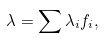Convert formula to latex. <formula><loc_0><loc_0><loc_500><loc_500>\lambda = \sum \lambda _ { i } f _ { i } ,</formula> 